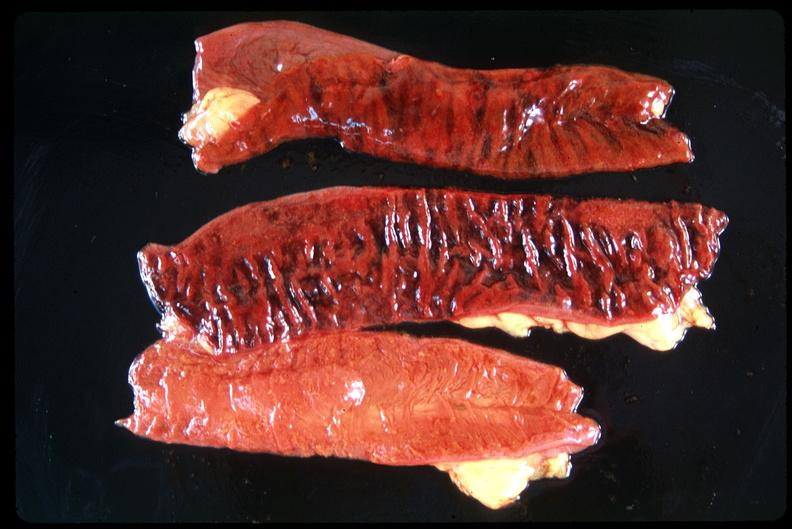what is present?
Answer the question using a single word or phrase. Gastrointestinal 